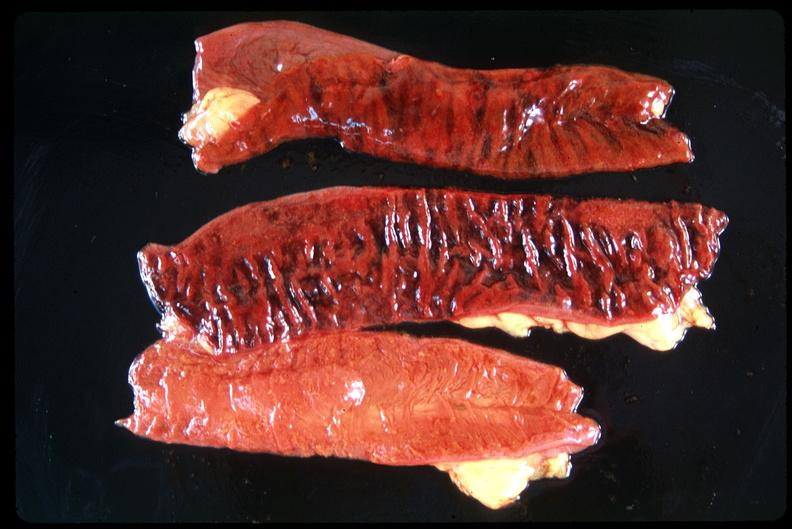what is present?
Answer the question using a single word or phrase. Gastrointestinal 